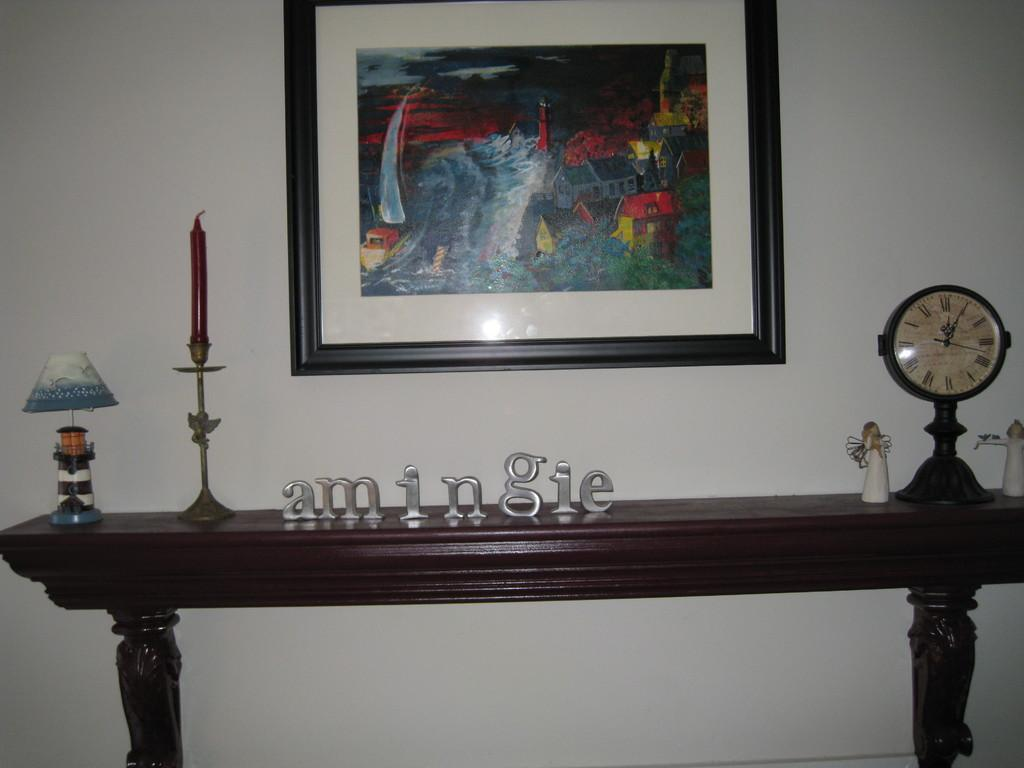Provide a one-sentence caption for the provided image. A table has the word amingie spelled out on top of it. 